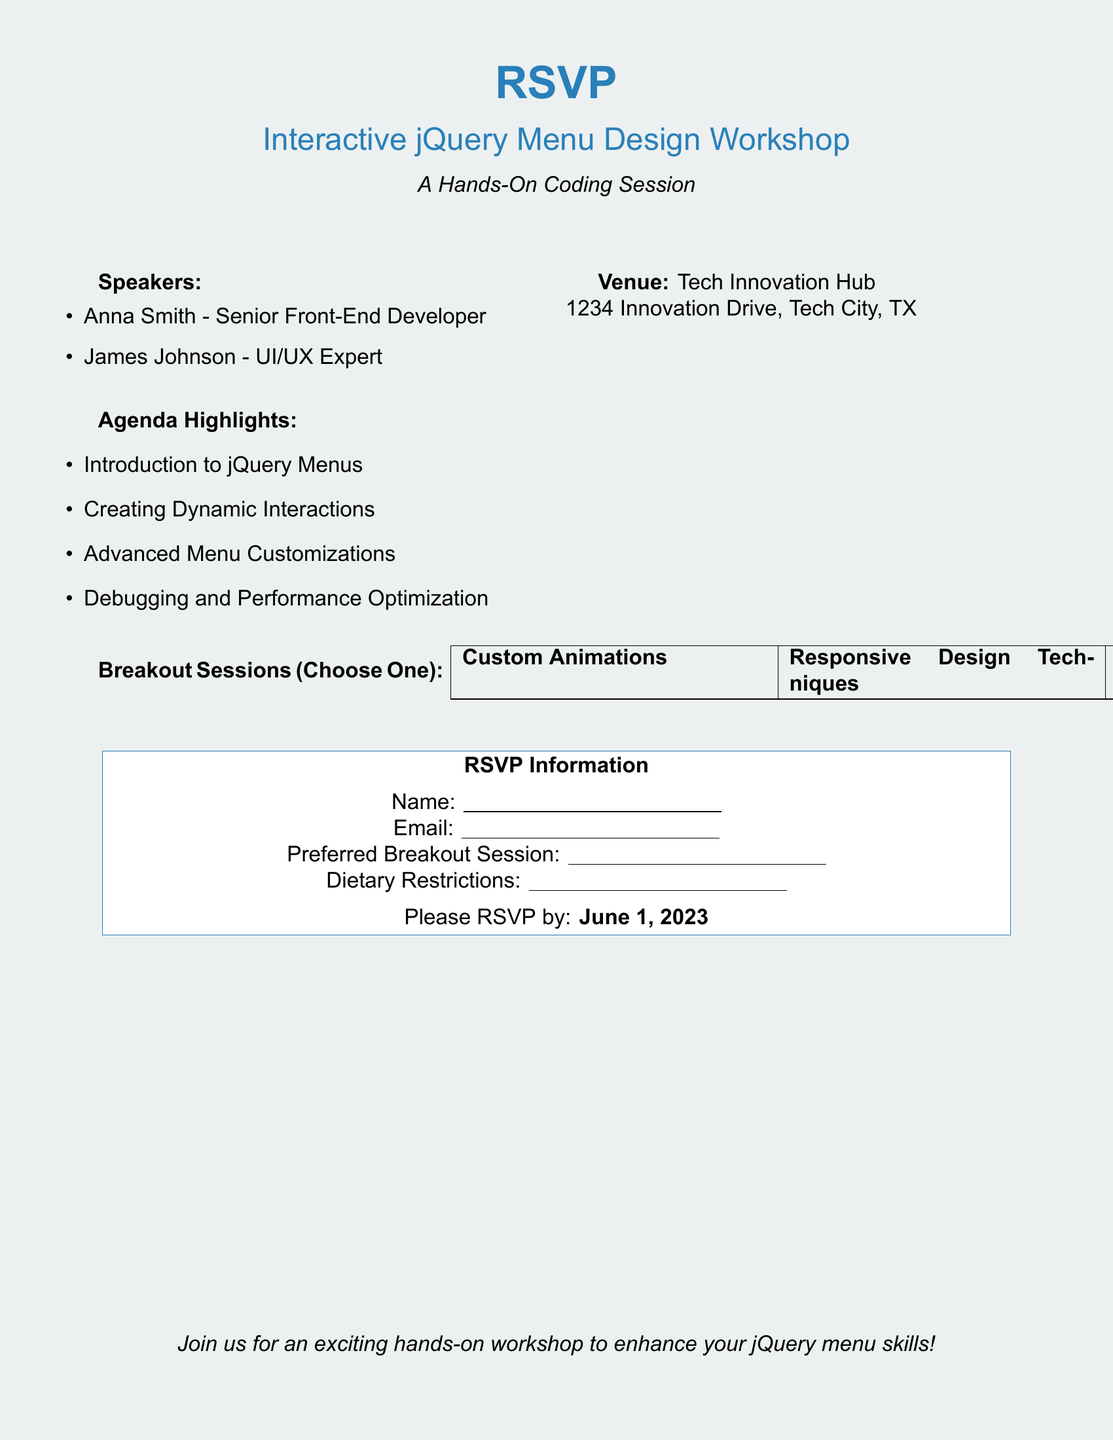What is the title of the workshop? The title of the workshop is stated at the beginning of the document as "Interactive jQuery Menu Design Workshop."
Answer: Interactive jQuery Menu Design Workshop Who are the speakers at the workshop? The speakers are listed in the document under the "Speakers" section.
Answer: Anna Smith, James Johnson What is the venue for the workshop? The venue information is provided in the document, detailing the location.
Answer: Tech Innovation Hub, 1234 Innovation Drive, Tech City, TX What are the dietary restrictions requested for RSVPs? The document includes a section for dietary restrictions as part of the RSVP information.
Answer: Dietary Restrictions What is the deadline for RSVPs? The deadline for RSVPs is specifically mentioned at the end of the RSVP information section.
Answer: June 1, 2023 What is one of the agenda highlights? The agenda highlights are listed in the document, each being a specific topic of discussion.
Answer: Introduction to jQuery Menus How many breakout sessions can participants choose from? The document lists the total number of breakout sessions available for selection.
Answer: Three What must attendees provide for RSVP? The RSVP information section outlines the details required for submission.
Answer: Name, Email, Preferred Breakout Session, Dietary Restrictions What is the primary focus of the workshop? The overall purpose of the workshop is mentioned in the introductory lines.
Answer: Hands-On Coding Session 